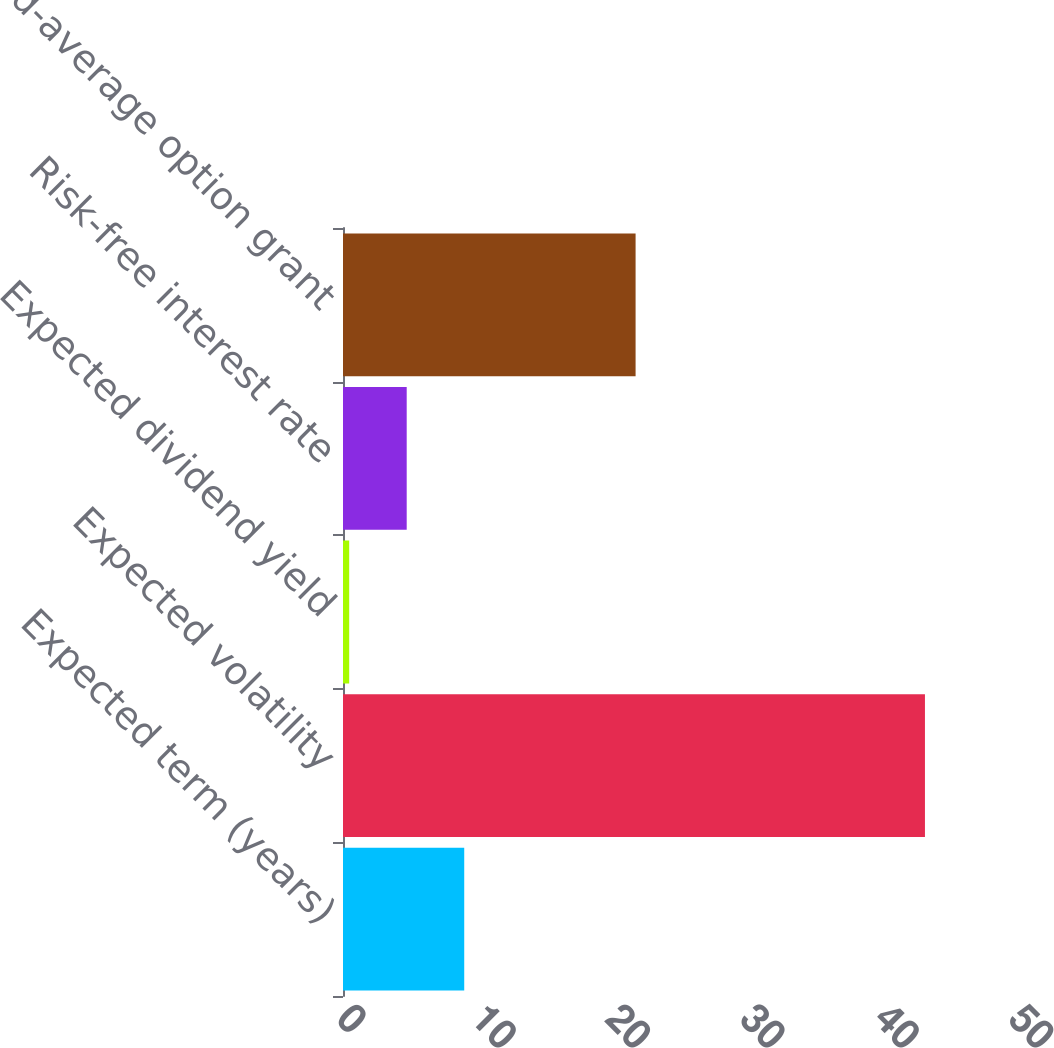Convert chart. <chart><loc_0><loc_0><loc_500><loc_500><bar_chart><fcel>Expected term (years)<fcel>Expected volatility<fcel>Expected dividend yield<fcel>Risk-free interest rate<fcel>Weighted-average option grant<nl><fcel>9.02<fcel>43.3<fcel>0.46<fcel>4.74<fcel>21.77<nl></chart> 